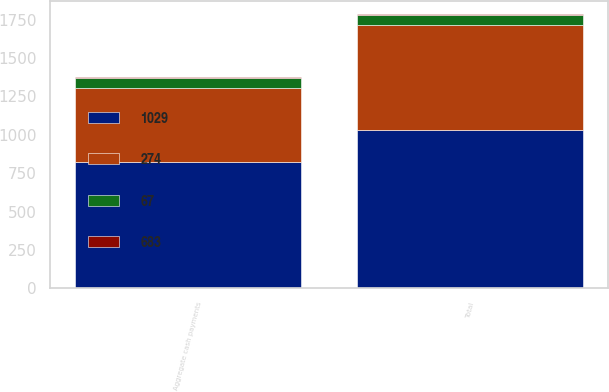<chart> <loc_0><loc_0><loc_500><loc_500><stacked_bar_chart><ecel><fcel>Aggregate cash payments<fcel>Total<nl><fcel>1029<fcel>825<fcel>1029<nl><fcel>274<fcel>479<fcel>683<nl><fcel>683<fcel>5<fcel>5<nl><fcel>67<fcel>67<fcel>67<nl></chart> 